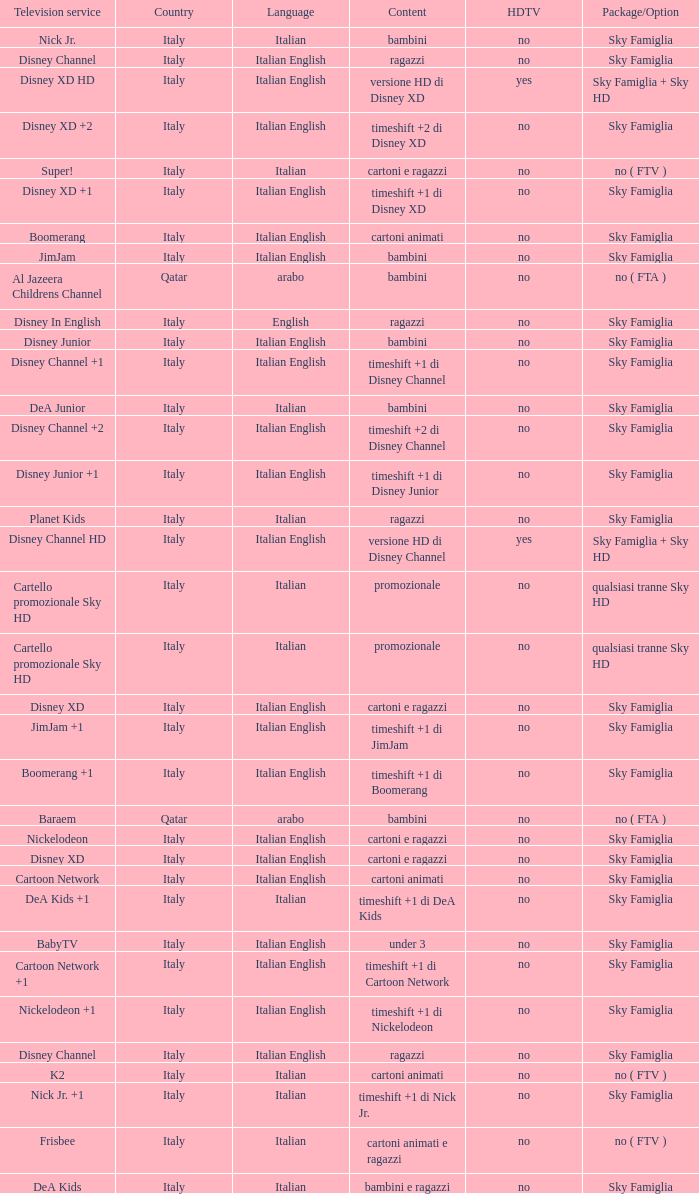What is the Country when the language is italian english, and the television service is disney xd +1? Italy. 